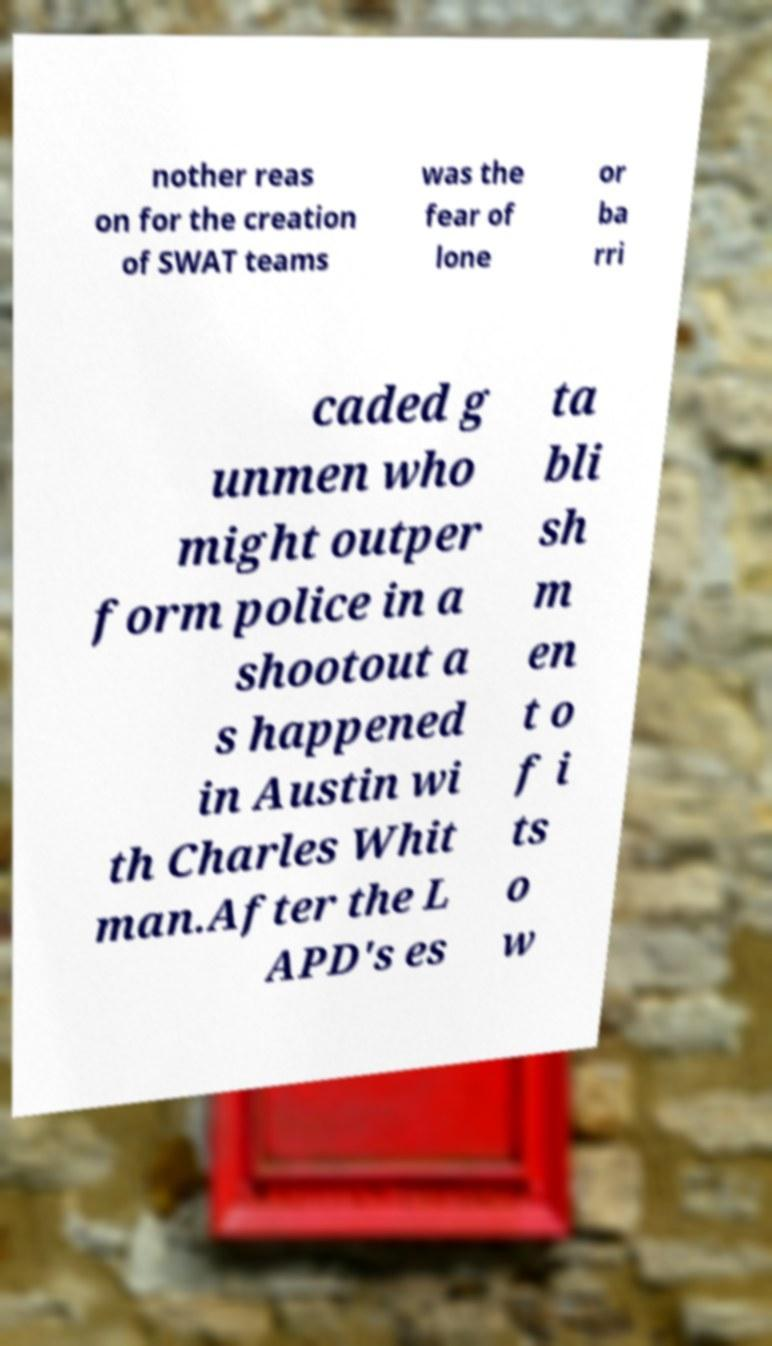Please read and relay the text visible in this image. What does it say? nother reas on for the creation of SWAT teams was the fear of lone or ba rri caded g unmen who might outper form police in a shootout a s happened in Austin wi th Charles Whit man.After the L APD's es ta bli sh m en t o f i ts o w 